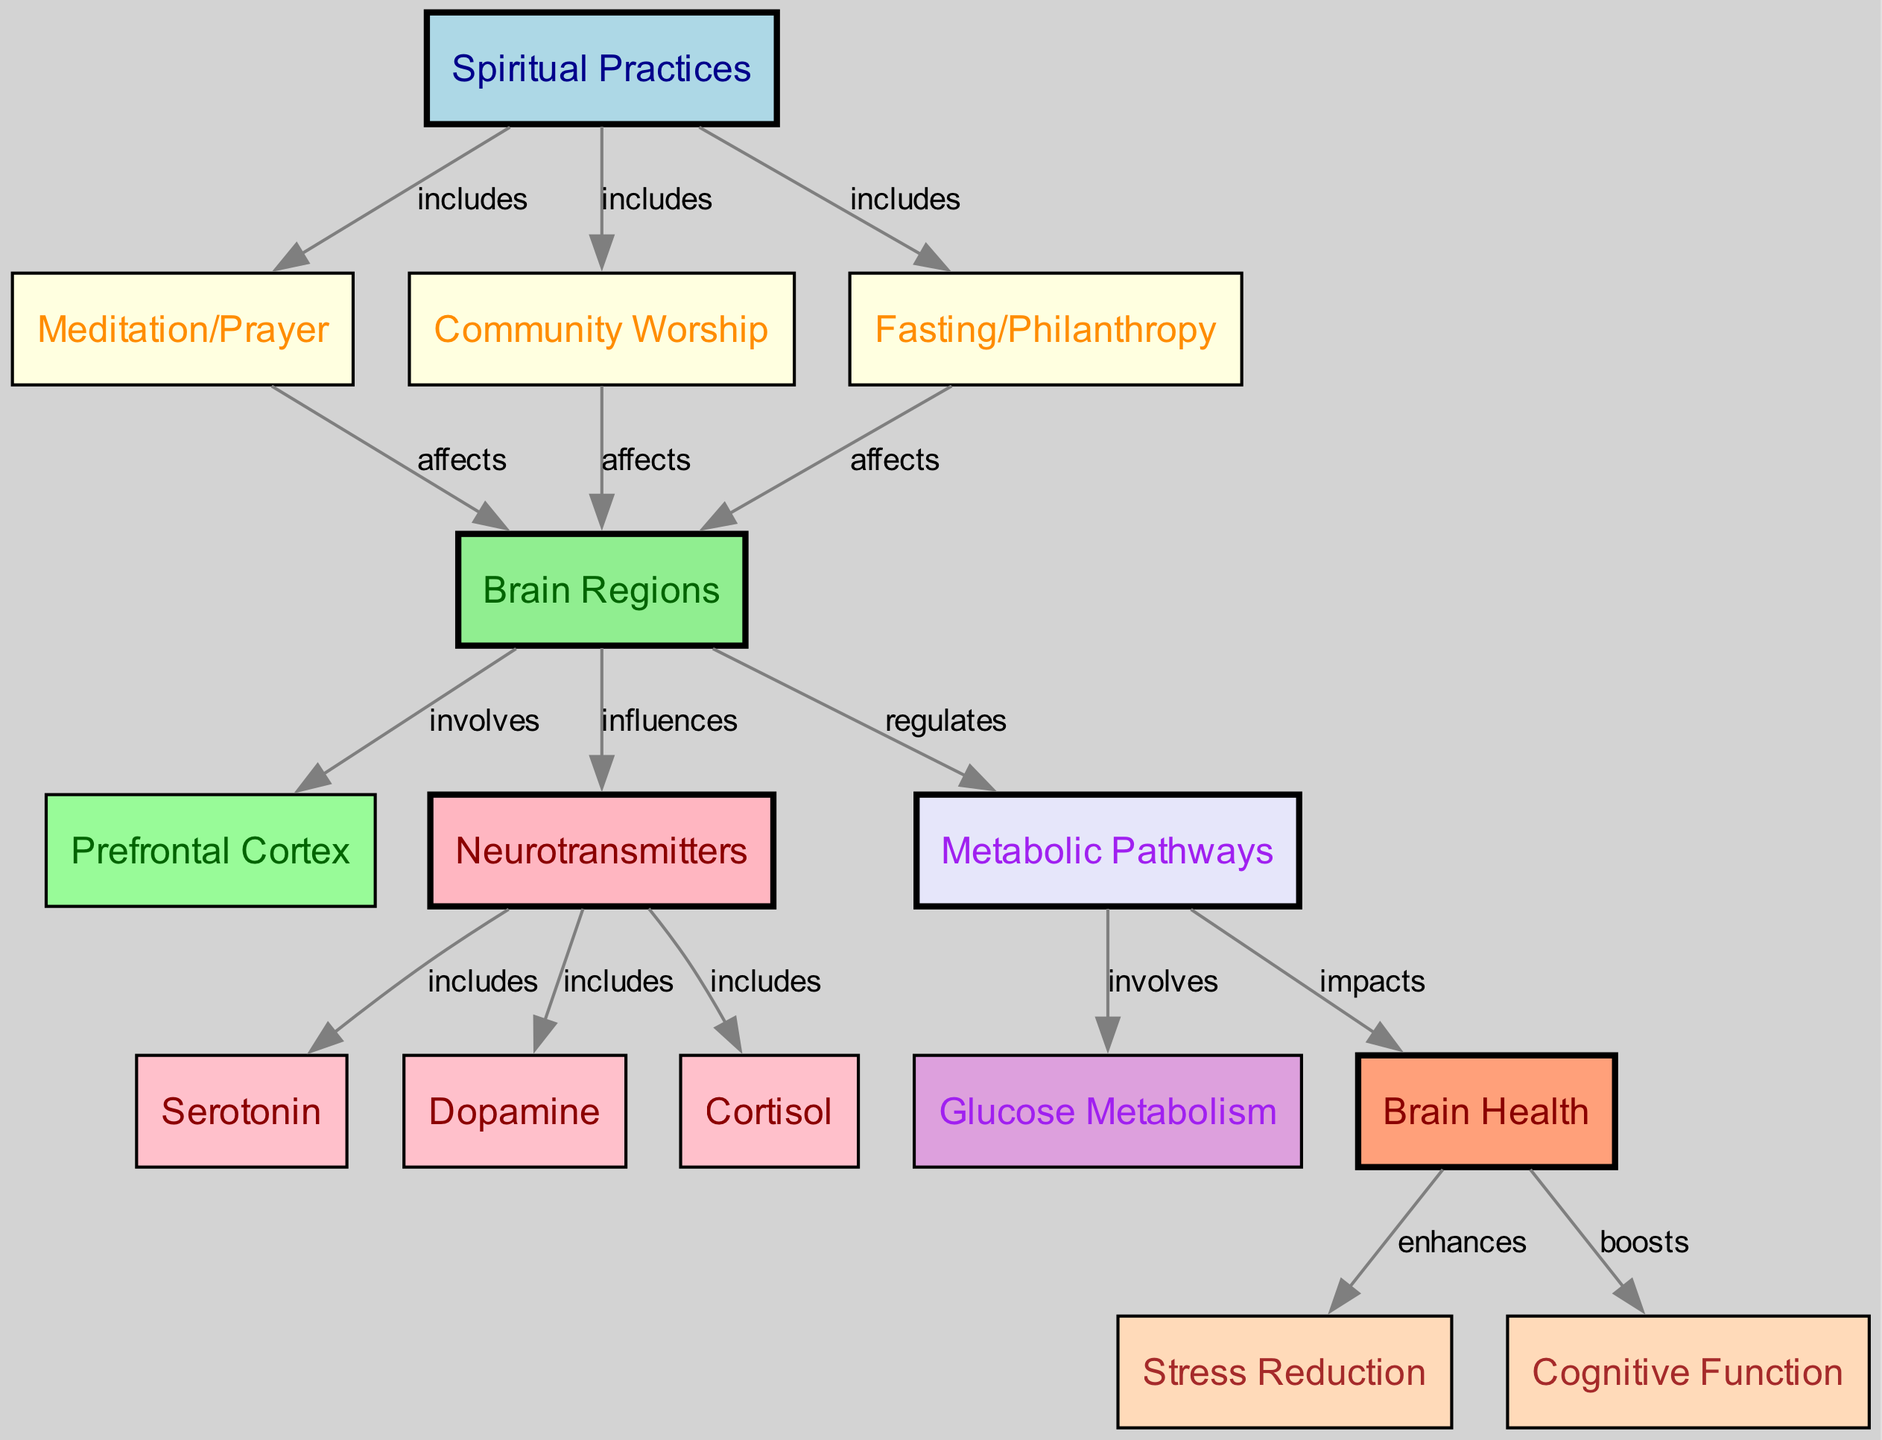What nodes are included in spiritual practices? The diagram indicates three nodes that are categorized under spiritual practices, which are Meditation/Prayer, Community Worship, and Fasting/Philanthropy. These nodes are directly connected to the spiritual practices node.
Answer: Meditation/Prayer, Community Worship, Fasting/Philanthropy How many edges connect to brain regions? The diagram shows multiple connections to the brain regions node. Specifically, there are three edges that connect from spiritual practices and an additional two edges connecting to other nodes: prefrontal cortex and neurotransmitters. In total, there are five edges leading to brain regions.
Answer: Five Which neurotransmitter is influenced by brain regions? The diagram specifies that neurotransmitters include three types: serotonin, dopamine, and cortisol. The relationship is direct as brain regions influence the neurotransmitters node.
Answer: Serotonin, Dopamine, Cortisol What impact do metabolic pathways have on brain health? According to the diagram, the metabolic pathways directly impact brain health. This connection shows the role of metabolic processes in shaping overall mental and cognitive functions.
Answer: Impacts How do spiritual practices affect cognitive function? Spiritual practices enhance brain health through their influence on brain regions, which then regulate metabolic pathways. Ultimately, brain health boosts cognitive function according to the diagram's flow. This reasoning combines the effects of spiritual practices culminating in improved cognitive outcomes.
Answer: Boosts What is enhanced by brain health? The diagram illustrates that brain health enhances stress reduction and boosts cognitive function. These connections identify the positive contributions of good brain health in managing stress levels and improving mental clarity.
Answer: Stress Reduction, Cognitive Function What type of spiritual practice affects the prefrontal cortex? The diagram shows that both meditation/prayer and community worship have an effect on brain regions, which involves the prefrontal cortex. Hence, both practices influence this specific area of the brain.
Answer: Meditation/Prayer, Community Worship Which metabolic pathway is involved in glucose metabolism? The diagram clearly states that glucose metabolism is one of the components indicated under metabolic pathways, reflecting an essential relationship within brain health processes.
Answer: Glucose Metabolism How many total nodes are present in the diagram? By counting the distinct nodes listed in the diagram, we find a total of fourteen unique nodes. This includes all categories ranging from spiritual practices to specific brain health factors.
Answer: Fourteen 